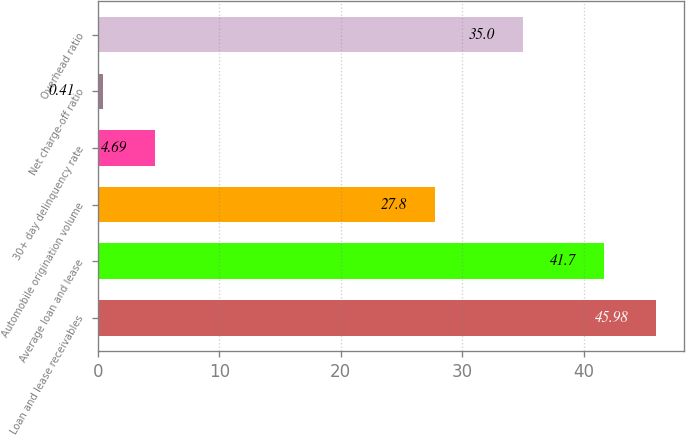Convert chart to OTSL. <chart><loc_0><loc_0><loc_500><loc_500><bar_chart><fcel>Loan and lease receivables<fcel>Average loan and lease<fcel>Automobile origination volume<fcel>30+ day delinquency rate<fcel>Net charge-off ratio<fcel>Overhead ratio<nl><fcel>45.98<fcel>41.7<fcel>27.8<fcel>4.69<fcel>0.41<fcel>35<nl></chart> 